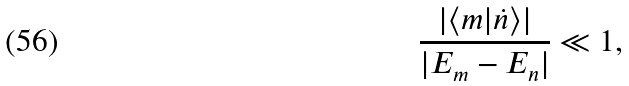Convert formula to latex. <formula><loc_0><loc_0><loc_500><loc_500>\frac { | \langle m | \dot { n } \rangle | } { | E _ { m } - E _ { n } | } \ll 1 ,</formula> 